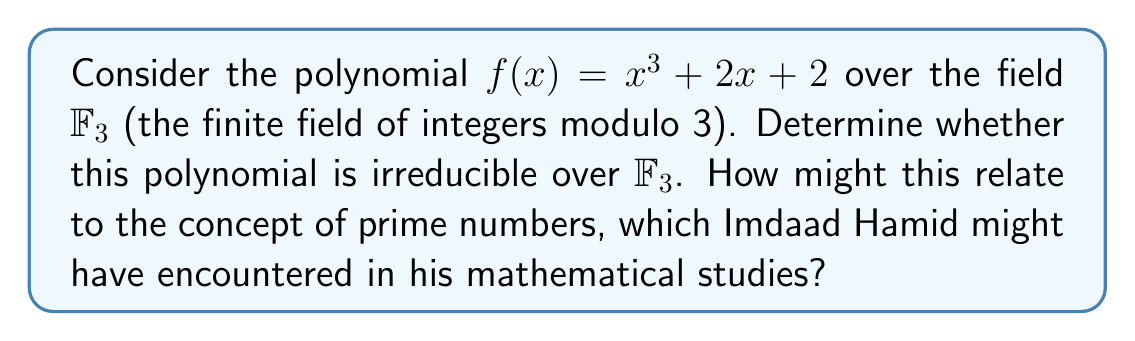What is the answer to this math problem? To determine if the polynomial $f(x) = x^3 + 2x + 2$ is irreducible over $\mathbb{F}_3$, we need to check if it has any factors of degree 1 or 2 in $\mathbb{F}_3$. 

Step 1: Check for linear factors
We need to check if there are any roots in $\mathbb{F}_3$. The possible values are 0, 1, and 2.

For $x = 0$: $f(0) = 0^3 + 2(0) + 2 = 2 \not\equiv 0 \pmod{3}$
For $x = 1$: $f(1) = 1^3 + 2(1) + 2 = 5 \equiv 2 \pmod{3} \not\equiv 0 \pmod{3}$
For $x = 2$: $f(2) = 2^3 + 2(2) + 2 = 12 \equiv 0 \pmod{3}$

We see that $x = 2$ is a root of $f(x)$ in $\mathbb{F}_3$. Therefore, $(x-2)$ is a factor of $f(x)$ in $\mathbb{F}_3$.

Step 2: Find the other factor
Since we found a linear factor, we can divide $f(x)$ by $(x-2)$ to find the other factor:

$$f(x) = (x-2)(x^2 + 2x + 1)$$

This factorization shows that $f(x)$ is reducible over $\mathbb{F}_3$.

Relating to prime numbers:
Just as prime numbers are the building blocks of integers, irreducible polynomials are the building blocks of polynomial rings. The concept of irreducibility for polynomials is analogous to primality for integers. In this case, $f(x)$ is not "prime" in the polynomial sense over $\mathbb{F}_3$, similar to how a composite number is not prime in the integer sense.

Imdaad Hamid, in his mathematical studies, would likely have encountered the importance of prime numbers in number theory. This polynomial irreducibility concept extends that idea to polynomial rings, showing how fundamental mathematical concepts can be generalized across different algebraic structures.
Answer: The polynomial $f(x) = x^3 + 2x + 2$ is reducible over $\mathbb{F}_3$, as it can be factored as $f(x) = (x-2)(x^2 + 2x + 1)$ in $\mathbb{F}_3$. 